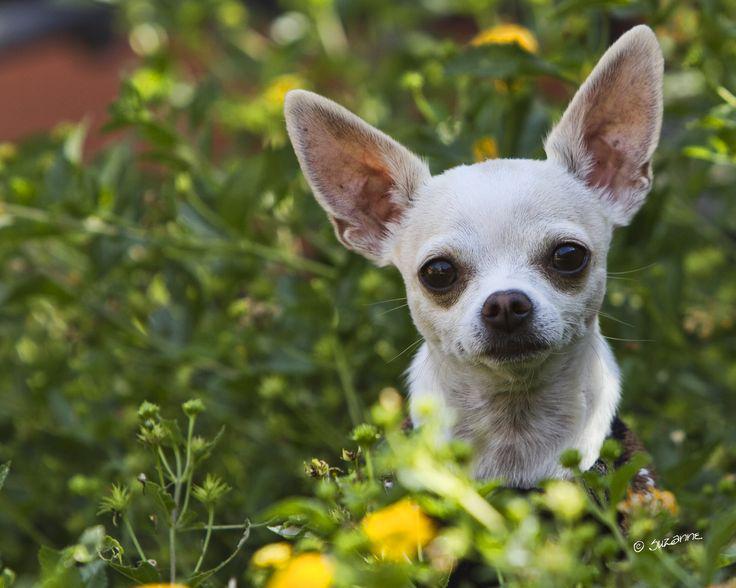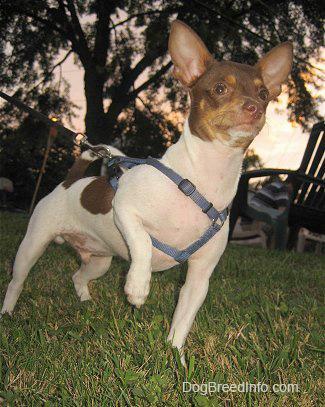The first image is the image on the left, the second image is the image on the right. Given the left and right images, does the statement "There are a total of two dogs between both images." hold true? Answer yes or no. Yes. The first image is the image on the left, the second image is the image on the right. For the images displayed, is the sentence "The left photo depicts two or more dogs outside in the grass." factually correct? Answer yes or no. No. 